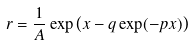<formula> <loc_0><loc_0><loc_500><loc_500>r = \frac { 1 } { A } \exp \left ( x - q \exp ( - p x ) \right )</formula> 